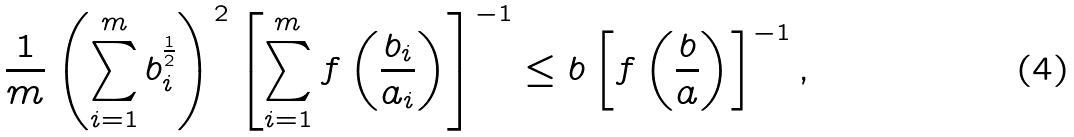Convert formula to latex. <formula><loc_0><loc_0><loc_500><loc_500>\frac { 1 } { m } \left ( \sum _ { i = 1 } ^ { m } b _ { i } ^ { \frac { 1 } { 2 } } \right ) ^ { 2 } \left [ \sum _ { i = 1 } ^ { m } f \left ( \frac { b _ { i } } { a _ { i } } \right ) \right ] ^ { - 1 } \leq b \left [ f \left ( \frac { b } { a } \right ) \right ] ^ { - 1 } ,</formula> 